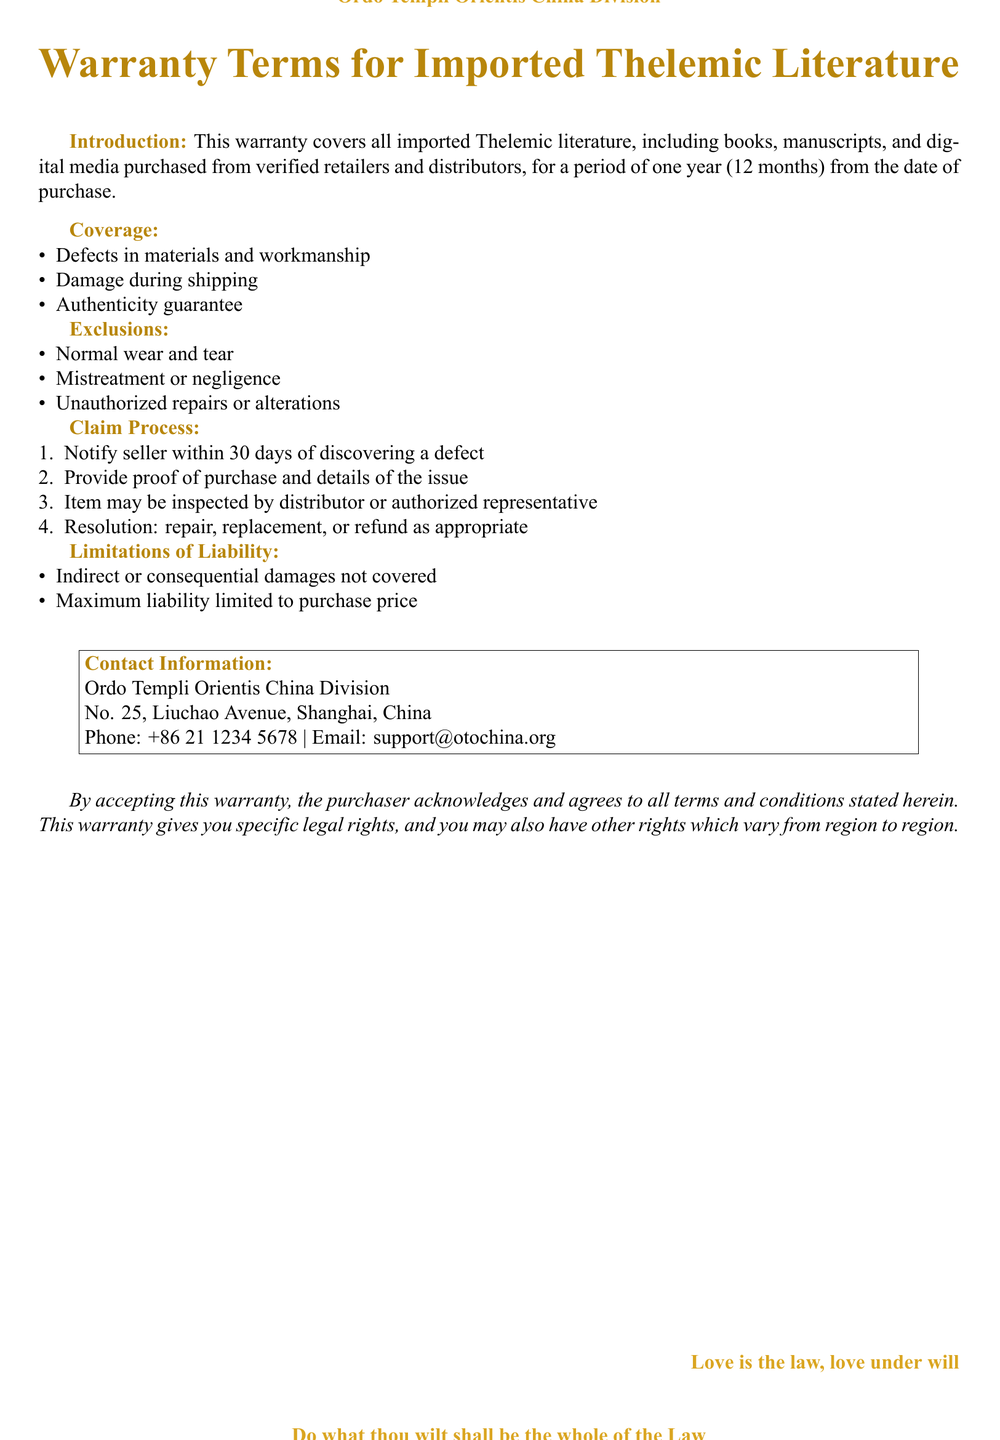What is the warranty period for imported Thelemic literature? The warranty period covers all imported Thelemic literature purchased from verified retailers for one year from the date of purchase.
Answer: one year What types of defects are covered by the warranty? The warranty covers defects in materials and workmanship as well as damage during shipping.
Answer: defects in materials and workmanship; damage during shipping What is excluded from the warranty? Excluded items include normal wear and tear, mistreatment or negligence, and unauthorized repairs or alterations.
Answer: normal wear and tear; mistreatment or negligence; unauthorized repairs or alterations How long do you have to notify the seller about a defect? Customers must notify the seller within 30 days of discovering a defect to initiate the claim process.
Answer: 30 days What is the maximum liability of the warranty? The maximum liability is limited to the purchase price of the item covered under the warranty.
Answer: purchase price What should you provide when making a claim? A claim requires proof of purchase and details of the issue to be provided to the seller.
Answer: proof of purchase and details of the issue What is the contact email for customer support? The document provides a specific email address for inquiries, which customers can use to contact support.
Answer: support@otochina.org Who is the warranty applicable to? The warranty is specifically designed for purchasers of imported Thelemic literature from verified retailers.
Answer: purchasers of imported Thelemic literature 